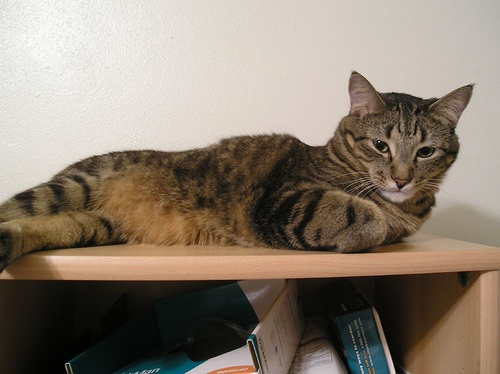Describe the objects in this image and their specific colors. I can see cat in lightgray, black, maroon, and gray tones and book in lightgray, black, blue, and gray tones in this image. 